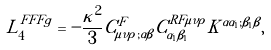Convert formula to latex. <formula><loc_0><loc_0><loc_500><loc_500>L _ { 4 } ^ { F F F g } = - \frac { \kappa ^ { 2 } } { 3 } C ^ { F } _ { \mu \nu \rho ; \alpha \beta } C ^ { R F \mu \nu \rho } _ { \alpha _ { 1 } \beta _ { 1 } } K ^ { \alpha \alpha _ { 1 } ; \beta _ { 1 } \beta } ,</formula> 